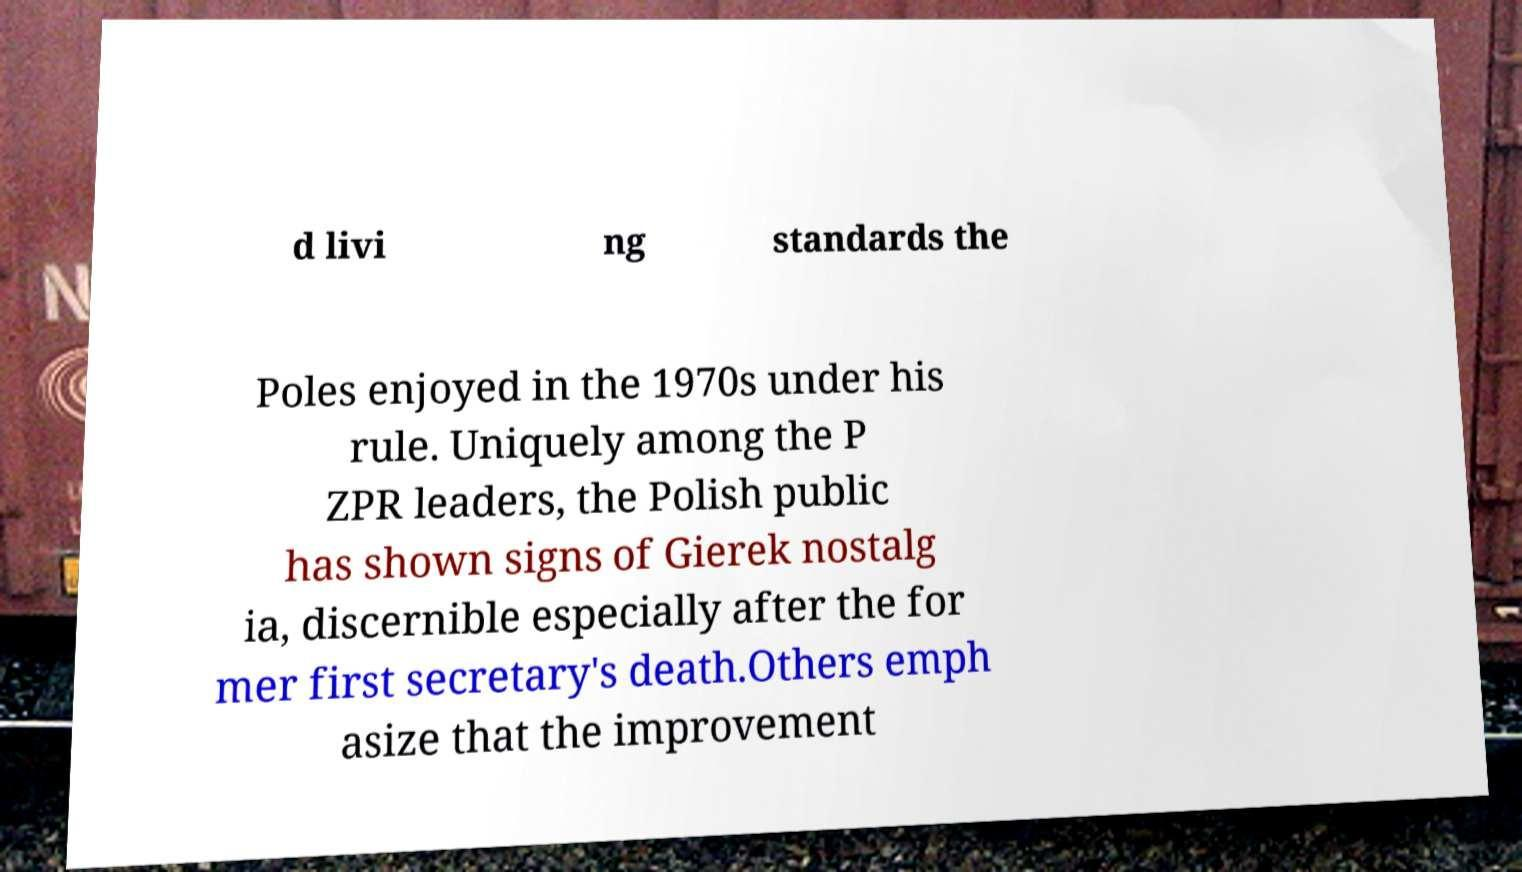Can you read and provide the text displayed in the image?This photo seems to have some interesting text. Can you extract and type it out for me? d livi ng standards the Poles enjoyed in the 1970s under his rule. Uniquely among the P ZPR leaders, the Polish public has shown signs of Gierek nostalg ia, discernible especially after the for mer first secretary's death.Others emph asize that the improvement 